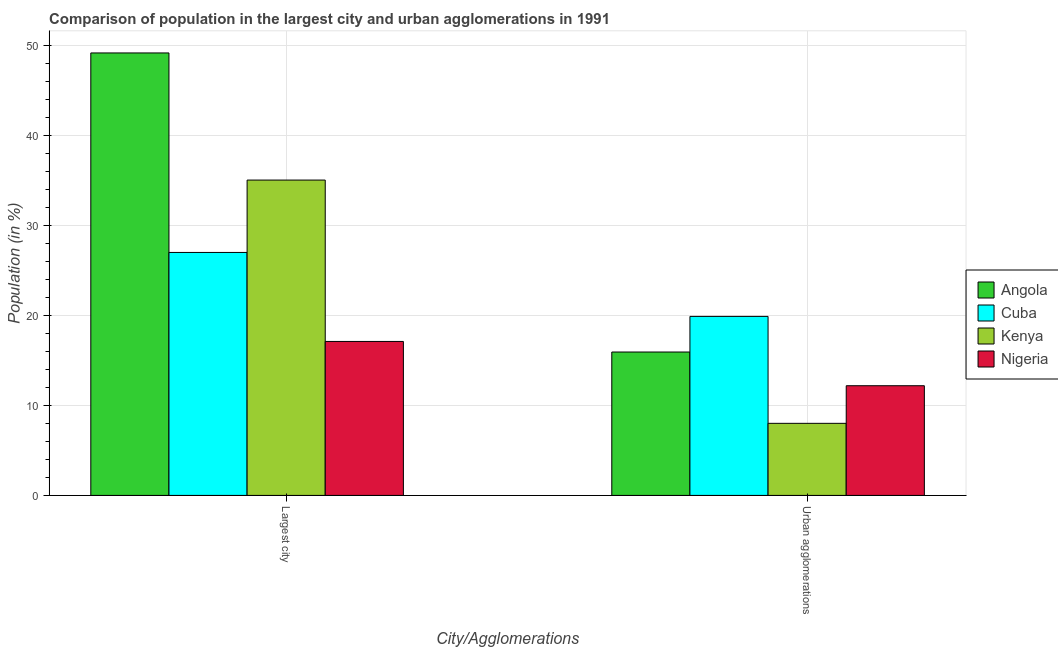Are the number of bars per tick equal to the number of legend labels?
Your answer should be compact. Yes. Are the number of bars on each tick of the X-axis equal?
Keep it short and to the point. Yes. How many bars are there on the 1st tick from the right?
Offer a very short reply. 4. What is the label of the 1st group of bars from the left?
Your response must be concise. Largest city. What is the population in urban agglomerations in Cuba?
Your response must be concise. 19.9. Across all countries, what is the maximum population in urban agglomerations?
Your answer should be very brief. 19.9. Across all countries, what is the minimum population in the largest city?
Ensure brevity in your answer.  17.12. In which country was the population in the largest city maximum?
Provide a succinct answer. Angola. In which country was the population in the largest city minimum?
Offer a very short reply. Nigeria. What is the total population in the largest city in the graph?
Make the answer very short. 128.39. What is the difference between the population in the largest city in Angola and that in Kenya?
Ensure brevity in your answer.  14.13. What is the difference between the population in urban agglomerations in Cuba and the population in the largest city in Nigeria?
Provide a short and direct response. 2.78. What is the average population in urban agglomerations per country?
Offer a terse response. 14.01. What is the difference between the population in urban agglomerations and population in the largest city in Kenya?
Offer a terse response. -27.05. What is the ratio of the population in the largest city in Kenya to that in Nigeria?
Offer a very short reply. 2.05. Is the population in urban agglomerations in Cuba less than that in Nigeria?
Your answer should be compact. No. What does the 3rd bar from the left in Largest city represents?
Offer a very short reply. Kenya. What does the 2nd bar from the right in Largest city represents?
Provide a succinct answer. Kenya. How many bars are there?
Offer a terse response. 8. Are all the bars in the graph horizontal?
Offer a very short reply. No. How many countries are there in the graph?
Offer a terse response. 4. Are the values on the major ticks of Y-axis written in scientific E-notation?
Keep it short and to the point. No. Does the graph contain any zero values?
Offer a terse response. No. Does the graph contain grids?
Your answer should be very brief. Yes. How many legend labels are there?
Provide a short and direct response. 4. What is the title of the graph?
Provide a short and direct response. Comparison of population in the largest city and urban agglomerations in 1991. Does "Belarus" appear as one of the legend labels in the graph?
Make the answer very short. No. What is the label or title of the X-axis?
Keep it short and to the point. City/Agglomerations. What is the label or title of the Y-axis?
Keep it short and to the point. Population (in %). What is the Population (in %) in Angola in Largest city?
Offer a terse response. 49.19. What is the Population (in %) of Cuba in Largest city?
Your answer should be compact. 27.01. What is the Population (in %) in Kenya in Largest city?
Keep it short and to the point. 35.06. What is the Population (in %) in Nigeria in Largest city?
Ensure brevity in your answer.  17.12. What is the Population (in %) in Angola in Urban agglomerations?
Offer a terse response. 15.94. What is the Population (in %) of Cuba in Urban agglomerations?
Provide a short and direct response. 19.9. What is the Population (in %) of Kenya in Urban agglomerations?
Make the answer very short. 8.01. What is the Population (in %) in Nigeria in Urban agglomerations?
Offer a terse response. 12.2. Across all City/Agglomerations, what is the maximum Population (in %) of Angola?
Your response must be concise. 49.19. Across all City/Agglomerations, what is the maximum Population (in %) in Cuba?
Your response must be concise. 27.01. Across all City/Agglomerations, what is the maximum Population (in %) in Kenya?
Make the answer very short. 35.06. Across all City/Agglomerations, what is the maximum Population (in %) in Nigeria?
Your answer should be very brief. 17.12. Across all City/Agglomerations, what is the minimum Population (in %) in Angola?
Give a very brief answer. 15.94. Across all City/Agglomerations, what is the minimum Population (in %) of Cuba?
Offer a terse response. 19.9. Across all City/Agglomerations, what is the minimum Population (in %) of Kenya?
Make the answer very short. 8.01. Across all City/Agglomerations, what is the minimum Population (in %) in Nigeria?
Make the answer very short. 12.2. What is the total Population (in %) in Angola in the graph?
Offer a terse response. 65.14. What is the total Population (in %) of Cuba in the graph?
Offer a very short reply. 46.92. What is the total Population (in %) in Kenya in the graph?
Give a very brief answer. 43.07. What is the total Population (in %) of Nigeria in the graph?
Provide a short and direct response. 29.31. What is the difference between the Population (in %) in Angola in Largest city and that in Urban agglomerations?
Offer a very short reply. 33.25. What is the difference between the Population (in %) in Cuba in Largest city and that in Urban agglomerations?
Offer a very short reply. 7.11. What is the difference between the Population (in %) of Kenya in Largest city and that in Urban agglomerations?
Your response must be concise. 27.05. What is the difference between the Population (in %) of Nigeria in Largest city and that in Urban agglomerations?
Make the answer very short. 4.92. What is the difference between the Population (in %) in Angola in Largest city and the Population (in %) in Cuba in Urban agglomerations?
Offer a terse response. 29.29. What is the difference between the Population (in %) in Angola in Largest city and the Population (in %) in Kenya in Urban agglomerations?
Provide a succinct answer. 41.18. What is the difference between the Population (in %) of Angola in Largest city and the Population (in %) of Nigeria in Urban agglomerations?
Your response must be concise. 37. What is the difference between the Population (in %) of Cuba in Largest city and the Population (in %) of Kenya in Urban agglomerations?
Your answer should be compact. 19. What is the difference between the Population (in %) of Cuba in Largest city and the Population (in %) of Nigeria in Urban agglomerations?
Make the answer very short. 14.82. What is the difference between the Population (in %) in Kenya in Largest city and the Population (in %) in Nigeria in Urban agglomerations?
Your answer should be very brief. 22.86. What is the average Population (in %) in Angola per City/Agglomerations?
Your response must be concise. 32.57. What is the average Population (in %) of Cuba per City/Agglomerations?
Ensure brevity in your answer.  23.46. What is the average Population (in %) of Kenya per City/Agglomerations?
Offer a very short reply. 21.54. What is the average Population (in %) in Nigeria per City/Agglomerations?
Keep it short and to the point. 14.66. What is the difference between the Population (in %) in Angola and Population (in %) in Cuba in Largest city?
Your answer should be compact. 22.18. What is the difference between the Population (in %) of Angola and Population (in %) of Kenya in Largest city?
Ensure brevity in your answer.  14.13. What is the difference between the Population (in %) of Angola and Population (in %) of Nigeria in Largest city?
Your response must be concise. 32.07. What is the difference between the Population (in %) in Cuba and Population (in %) in Kenya in Largest city?
Make the answer very short. -8.05. What is the difference between the Population (in %) in Cuba and Population (in %) in Nigeria in Largest city?
Keep it short and to the point. 9.89. What is the difference between the Population (in %) of Kenya and Population (in %) of Nigeria in Largest city?
Offer a terse response. 17.94. What is the difference between the Population (in %) in Angola and Population (in %) in Cuba in Urban agglomerations?
Ensure brevity in your answer.  -3.96. What is the difference between the Population (in %) of Angola and Population (in %) of Kenya in Urban agglomerations?
Provide a succinct answer. 7.93. What is the difference between the Population (in %) in Angola and Population (in %) in Nigeria in Urban agglomerations?
Provide a short and direct response. 3.75. What is the difference between the Population (in %) of Cuba and Population (in %) of Kenya in Urban agglomerations?
Provide a short and direct response. 11.89. What is the difference between the Population (in %) of Cuba and Population (in %) of Nigeria in Urban agglomerations?
Offer a terse response. 7.71. What is the difference between the Population (in %) in Kenya and Population (in %) in Nigeria in Urban agglomerations?
Make the answer very short. -4.18. What is the ratio of the Population (in %) in Angola in Largest city to that in Urban agglomerations?
Your answer should be compact. 3.09. What is the ratio of the Population (in %) in Cuba in Largest city to that in Urban agglomerations?
Keep it short and to the point. 1.36. What is the ratio of the Population (in %) in Kenya in Largest city to that in Urban agglomerations?
Your answer should be compact. 4.37. What is the ratio of the Population (in %) of Nigeria in Largest city to that in Urban agglomerations?
Your answer should be compact. 1.4. What is the difference between the highest and the second highest Population (in %) of Angola?
Your answer should be very brief. 33.25. What is the difference between the highest and the second highest Population (in %) in Cuba?
Make the answer very short. 7.11. What is the difference between the highest and the second highest Population (in %) of Kenya?
Make the answer very short. 27.05. What is the difference between the highest and the second highest Population (in %) of Nigeria?
Your response must be concise. 4.92. What is the difference between the highest and the lowest Population (in %) of Angola?
Ensure brevity in your answer.  33.25. What is the difference between the highest and the lowest Population (in %) in Cuba?
Your answer should be compact. 7.11. What is the difference between the highest and the lowest Population (in %) in Kenya?
Provide a short and direct response. 27.05. What is the difference between the highest and the lowest Population (in %) of Nigeria?
Offer a terse response. 4.92. 